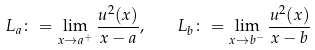<formula> <loc_0><loc_0><loc_500><loc_500>L _ { a } \colon = \lim _ { x \to a ^ { + } } \frac { u ^ { 2 } ( x ) } { x - a } , \quad L _ { b } \colon = \lim _ { x \to b ^ { - } } \frac { u ^ { 2 } ( x ) } { x - b }</formula> 